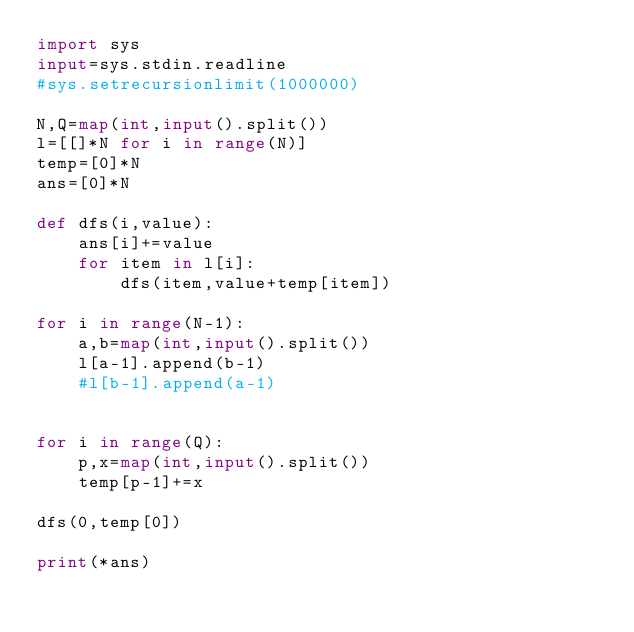Convert code to text. <code><loc_0><loc_0><loc_500><loc_500><_Python_>import sys
input=sys.stdin.readline
#sys.setrecursionlimit(1000000)

N,Q=map(int,input().split())
l=[[]*N for i in range(N)]
temp=[0]*N
ans=[0]*N

def dfs(i,value):
    ans[i]+=value
    for item in l[i]:
        dfs(item,value+temp[item])

for i in range(N-1):
    a,b=map(int,input().split())
    l[a-1].append(b-1)
    #l[b-1].append(a-1)


for i in range(Q):
    p,x=map(int,input().split())
    temp[p-1]+=x

dfs(0,temp[0])

print(*ans)
</code> 